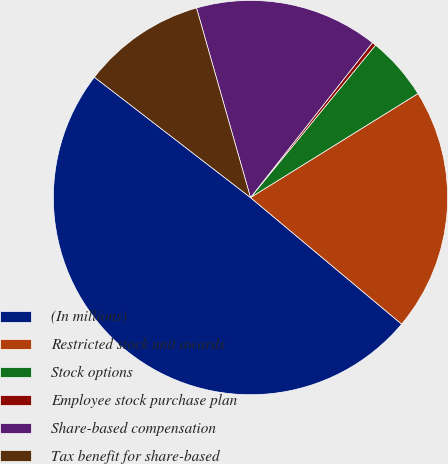Convert chart to OTSL. <chart><loc_0><loc_0><loc_500><loc_500><pie_chart><fcel>(In millions)<fcel>Restricted stock unit awards<fcel>Stock options<fcel>Employee stock purchase plan<fcel>Share-based compensation<fcel>Tax benefit for share-based<nl><fcel>49.36%<fcel>19.94%<fcel>5.22%<fcel>0.32%<fcel>15.03%<fcel>10.13%<nl></chart> 